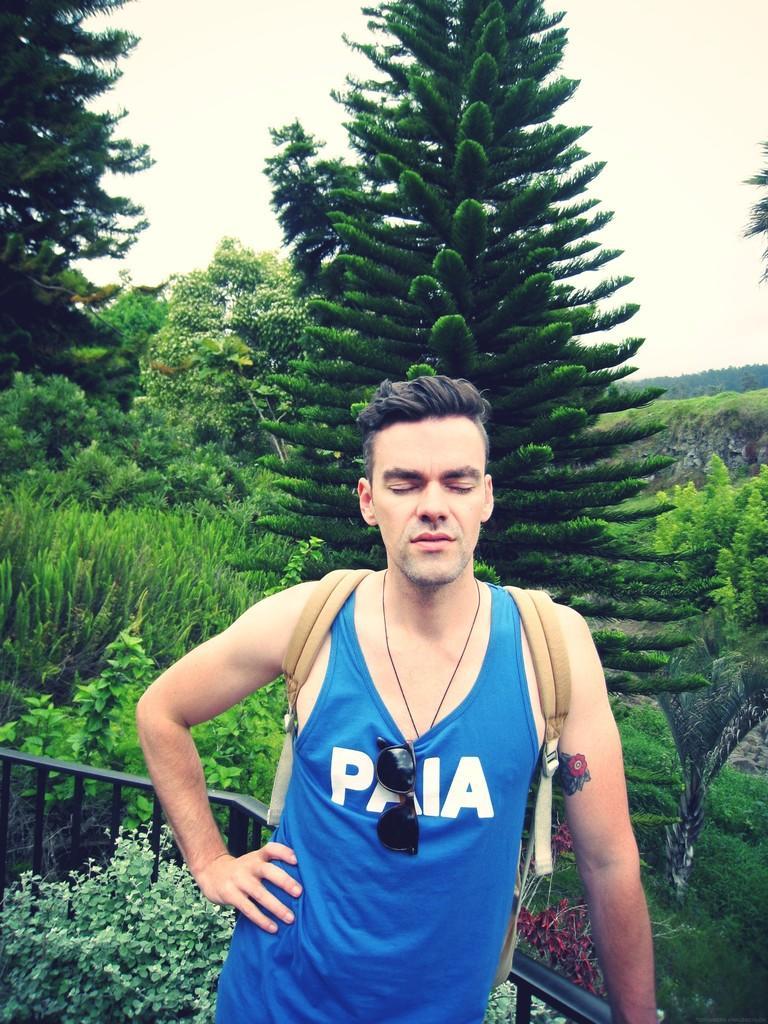Please provide a concise description of this image. In this image, we can see some plants and trees. There is a person at the bottom of the image wearing clothes. There is a sky at the top of the image. There is a safety barrier in the bottom left of the image. 